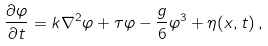<formula> <loc_0><loc_0><loc_500><loc_500>\frac { \partial \varphi } { \partial t } = k \nabla ^ { 2 } \varphi + \tau \varphi - \frac { g } { 6 } \varphi ^ { 3 } + \eta ( { x } , t ) \, ,</formula> 